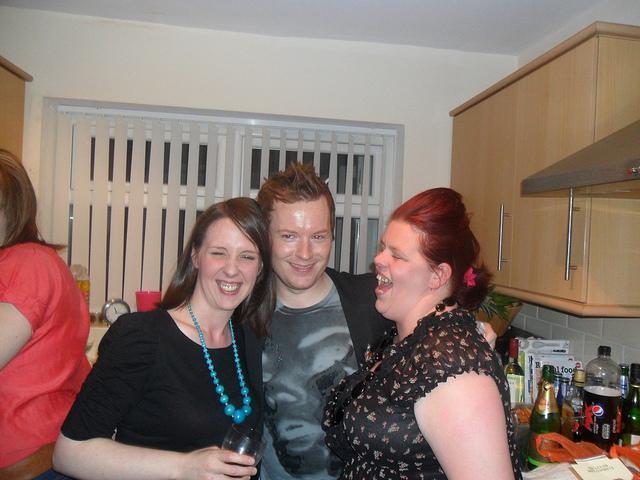How many people have red hair?
Give a very brief answer. 1. How many ladies are wearing a crown?
Give a very brief answer. 0. How many people are visible?
Give a very brief answer. 4. How many bottles are there?
Give a very brief answer. 2. 